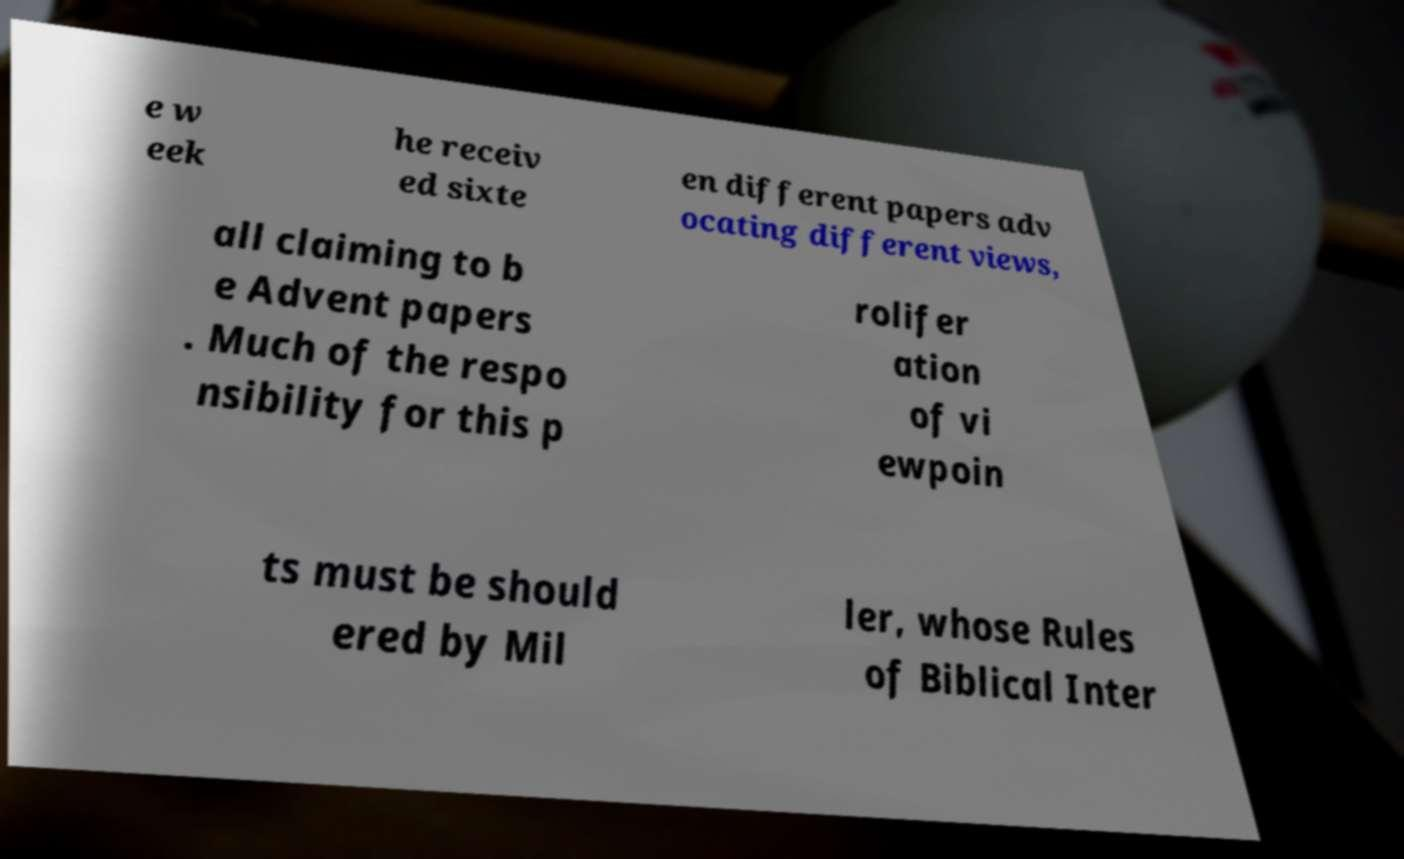Please identify and transcribe the text found in this image. e w eek he receiv ed sixte en different papers adv ocating different views, all claiming to b e Advent papers . Much of the respo nsibility for this p rolifer ation of vi ewpoin ts must be should ered by Mil ler, whose Rules of Biblical Inter 